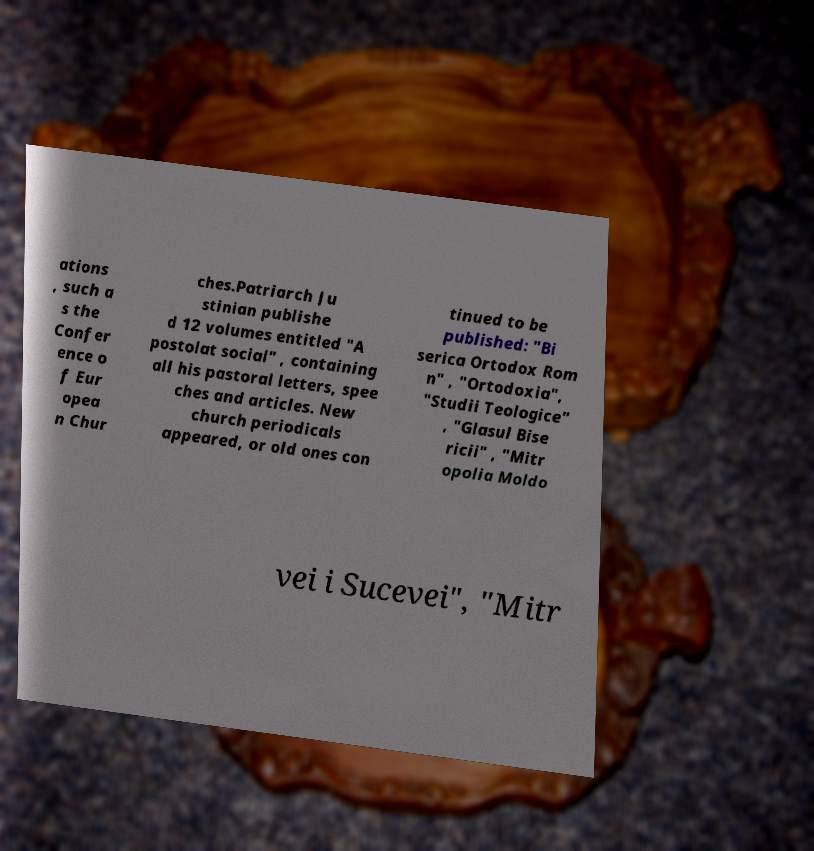Please identify and transcribe the text found in this image. ations , such a s the Confer ence o f Eur opea n Chur ches.Patriarch Ju stinian publishe d 12 volumes entitled "A postolat social" , containing all his pastoral letters, spee ches and articles. New church periodicals appeared, or old ones con tinued to be published: "Bi serica Ortodox Rom n" , "Ortodoxia", "Studii Teologice" , "Glasul Bise ricii" , "Mitr opolia Moldo vei i Sucevei", "Mitr 